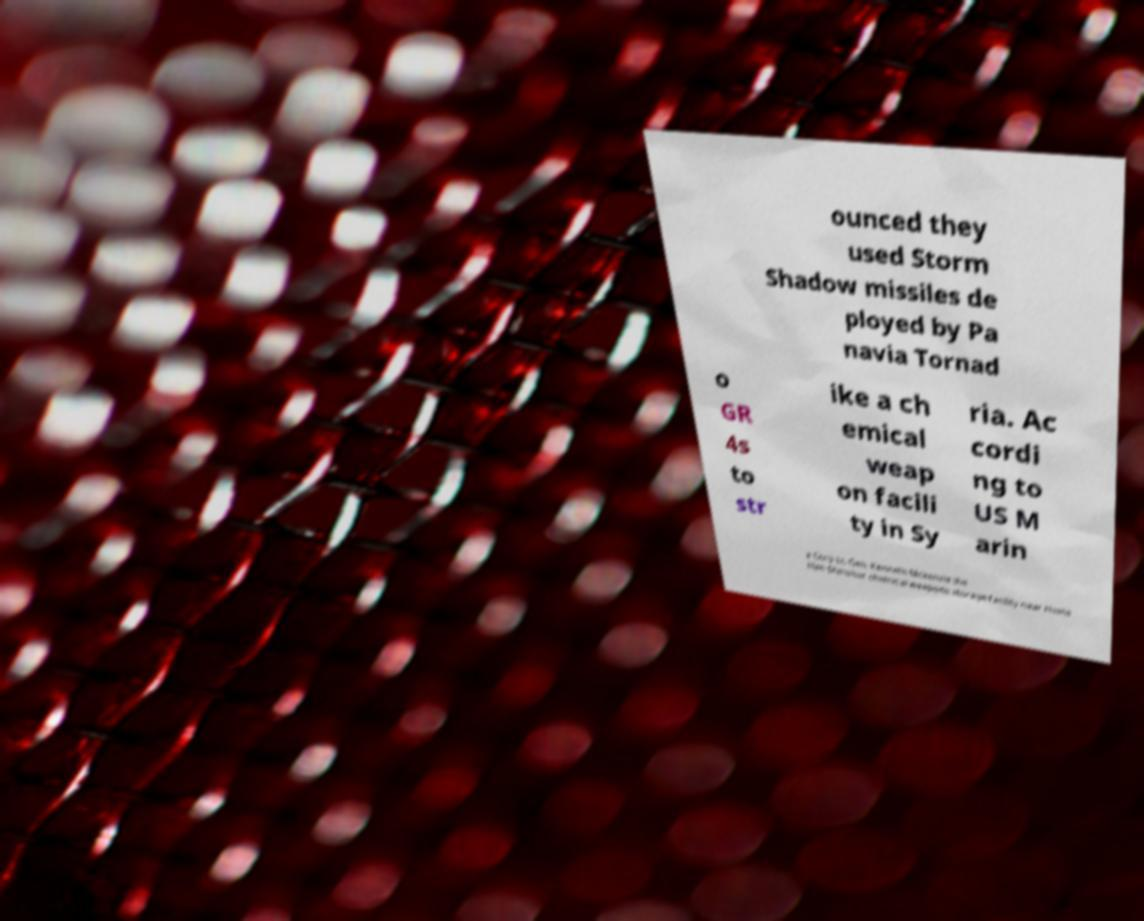Can you read and provide the text displayed in the image?This photo seems to have some interesting text. Can you extract and type it out for me? ounced they used Storm Shadow missiles de ployed by Pa navia Tornad o GR 4s to str ike a ch emical weap on facili ty in Sy ria. Ac cordi ng to US M arin e Corp Lt. Gen. Kenneth Mckenzie the Him Shinshar chemical weapons storage facility near Homs 